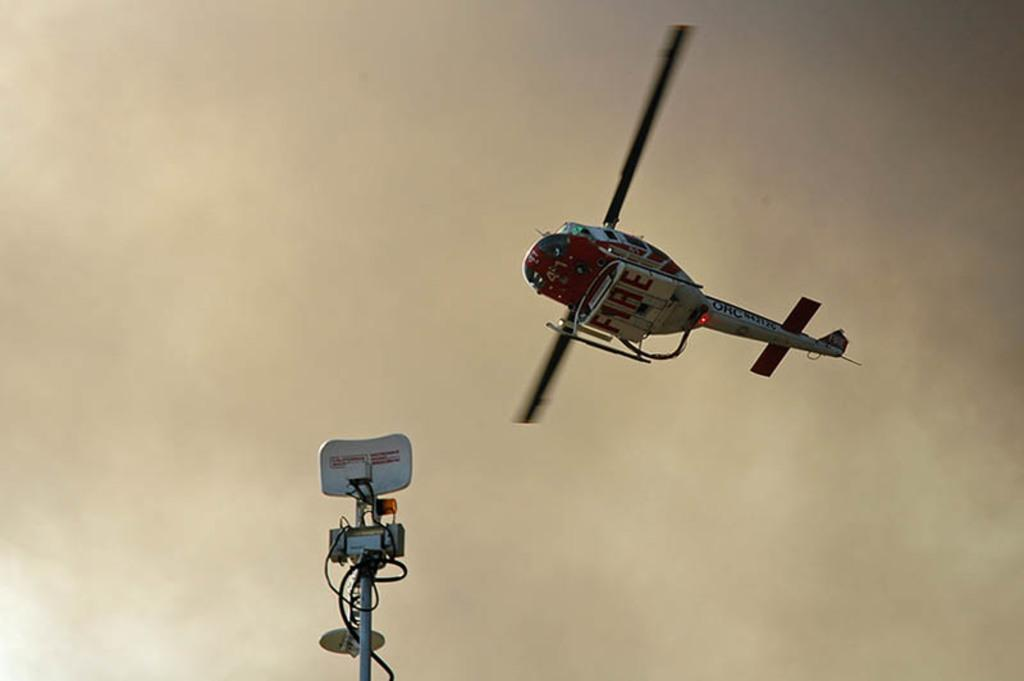<image>
Relay a brief, clear account of the picture shown. A fire department helicopter hovers overhead in a smoky sky. 